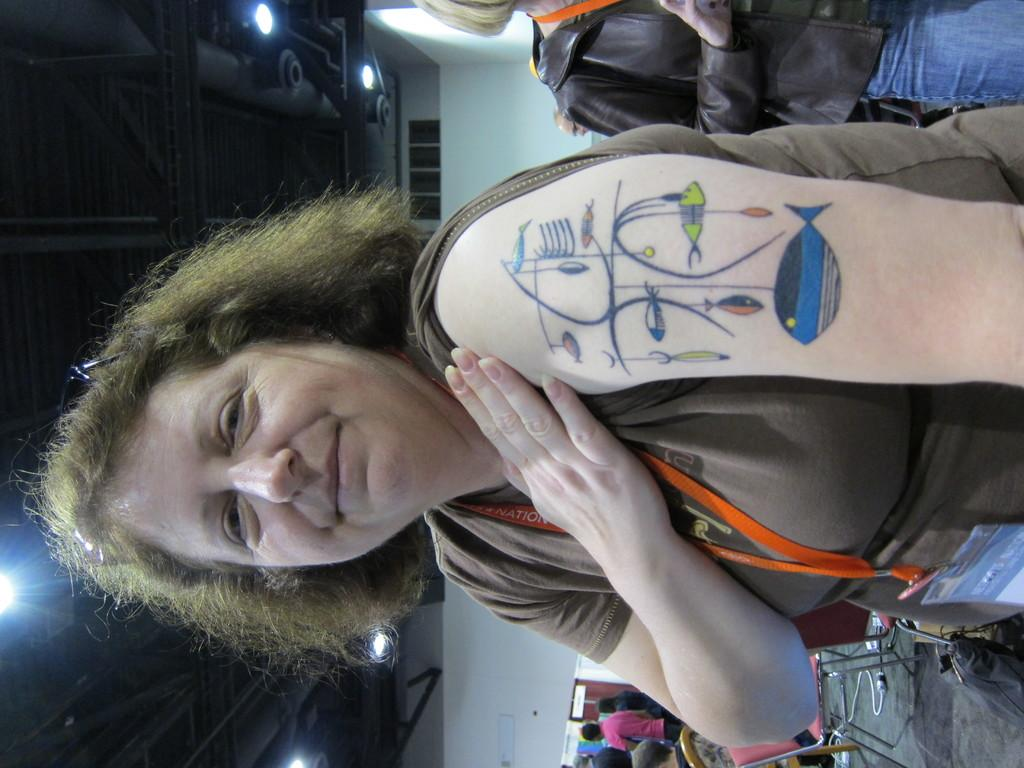What is the main subject of the image? There is a woman standing in the image. Can you describe any distinguishing features of the woman? The woman has a tattoo on her shoulder. What is the woman wearing around her neck? The woman is wearing an ID card around her neck. Are there any other people visible in the image? Yes, there are other people standing behind the woman. What type of meal is the woman giving advice about in the image? There is no meal or advice-giving activity depicted in the image; it simply shows a woman standing with an ID card and a tattoo. 